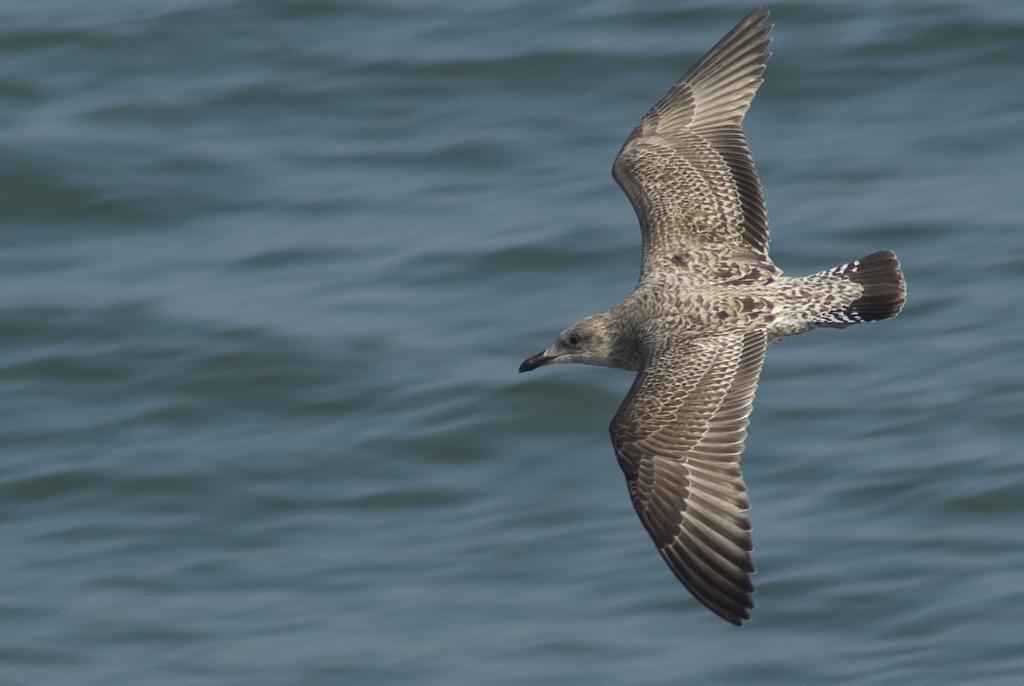Can you describe this image briefly? There is a bird flying in the foreground and water in the background area. 